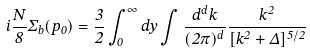<formula> <loc_0><loc_0><loc_500><loc_500>i \frac { N } { 8 } \Sigma _ { b } ( p _ { 0 } ) = \frac { 3 } { 2 } \int _ { 0 } ^ { \infty } d y \int \frac { d ^ { d } k } { ( 2 \pi ) ^ { d } } \frac { k ^ { 2 } } { [ \vec { k } ^ { 2 } + \Delta ] ^ { 5 / 2 } }</formula> 